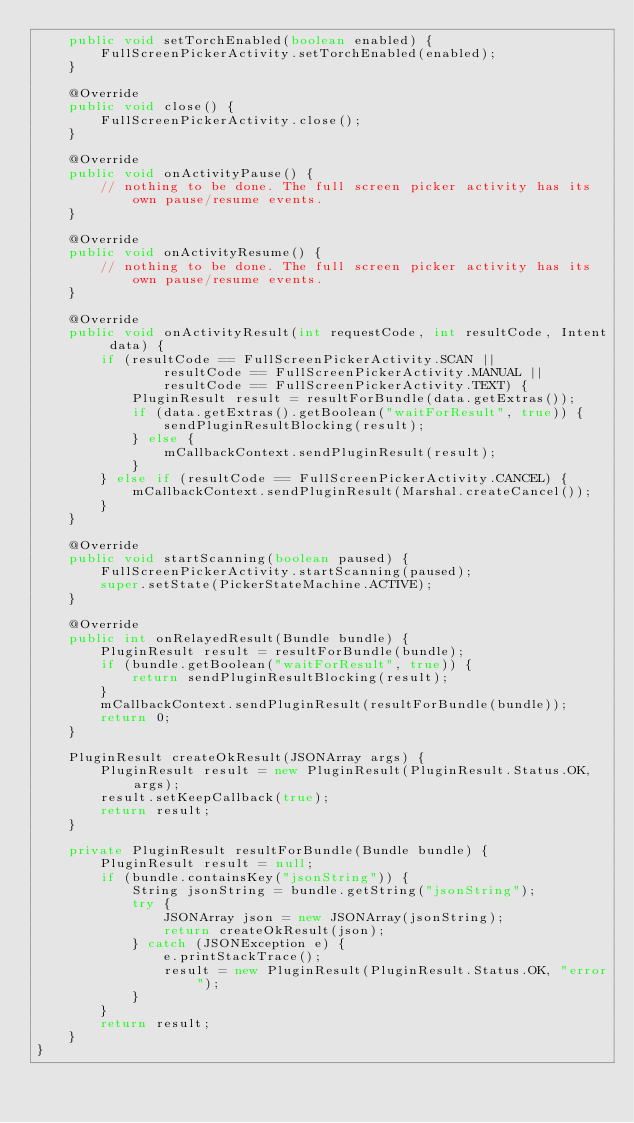<code> <loc_0><loc_0><loc_500><loc_500><_Java_>    public void setTorchEnabled(boolean enabled) {
        FullScreenPickerActivity.setTorchEnabled(enabled);
    }

    @Override
    public void close() {
        FullScreenPickerActivity.close();
    }

    @Override
    public void onActivityPause() {
        // nothing to be done. The full screen picker activity has its own pause/resume events.
    }

    @Override
    public void onActivityResume() {
        // nothing to be done. The full screen picker activity has its own pause/resume events.
    }

    @Override
    public void onActivityResult(int requestCode, int resultCode, Intent data) {
        if (resultCode == FullScreenPickerActivity.SCAN ||
                resultCode == FullScreenPickerActivity.MANUAL ||
                resultCode == FullScreenPickerActivity.TEXT) {
            PluginResult result = resultForBundle(data.getExtras());
            if (data.getExtras().getBoolean("waitForResult", true)) {
                sendPluginResultBlocking(result);
            } else {
                mCallbackContext.sendPluginResult(result);
            }
        } else if (resultCode == FullScreenPickerActivity.CANCEL) {
            mCallbackContext.sendPluginResult(Marshal.createCancel());
        }
    }

    @Override
    public void startScanning(boolean paused) {
        FullScreenPickerActivity.startScanning(paused);
        super.setState(PickerStateMachine.ACTIVE);
    }

    @Override
    public int onRelayedResult(Bundle bundle) {
        PluginResult result = resultForBundle(bundle);
        if (bundle.getBoolean("waitForResult", true)) {
            return sendPluginResultBlocking(result);
        }
        mCallbackContext.sendPluginResult(resultForBundle(bundle));
        return 0;
    }

    PluginResult createOkResult(JSONArray args) {
        PluginResult result = new PluginResult(PluginResult.Status.OK, args);
        result.setKeepCallback(true);
        return result;
    }

    private PluginResult resultForBundle(Bundle bundle) {
        PluginResult result = null;
        if (bundle.containsKey("jsonString")) {
            String jsonString = bundle.getString("jsonString");
            try {
                JSONArray json = new JSONArray(jsonString);
                return createOkResult(json);
            } catch (JSONException e) {
                e.printStackTrace();
                result = new PluginResult(PluginResult.Status.OK, "error");
            }
        }
        return result;
    }
}
</code> 